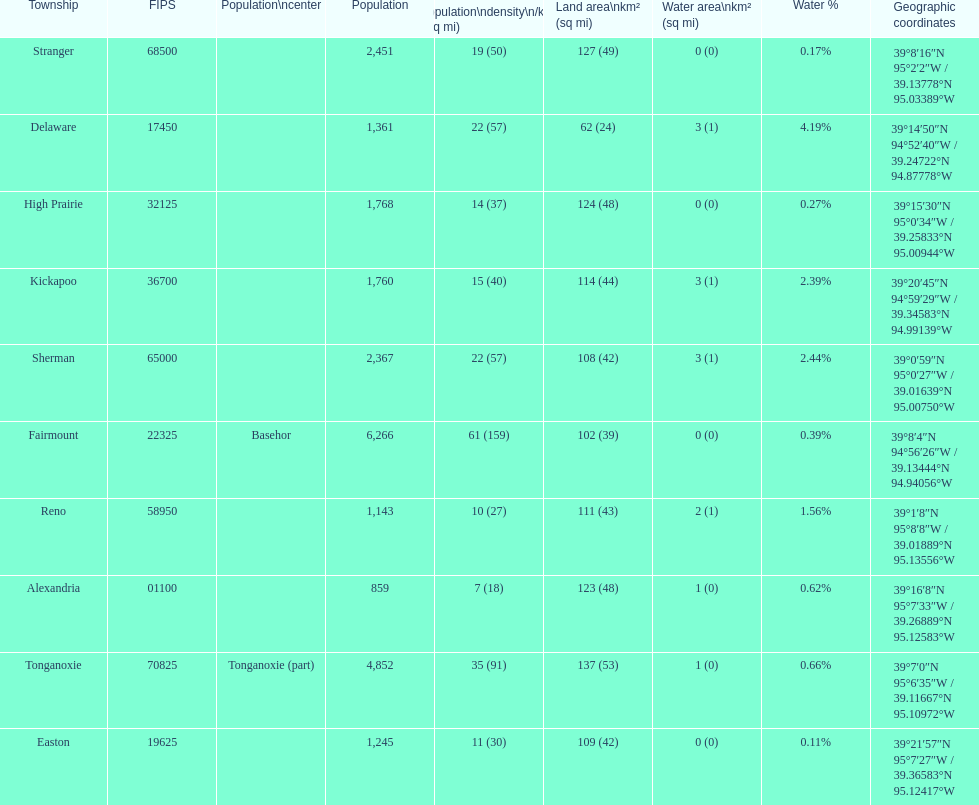Which township has the least land area? Delaware. 